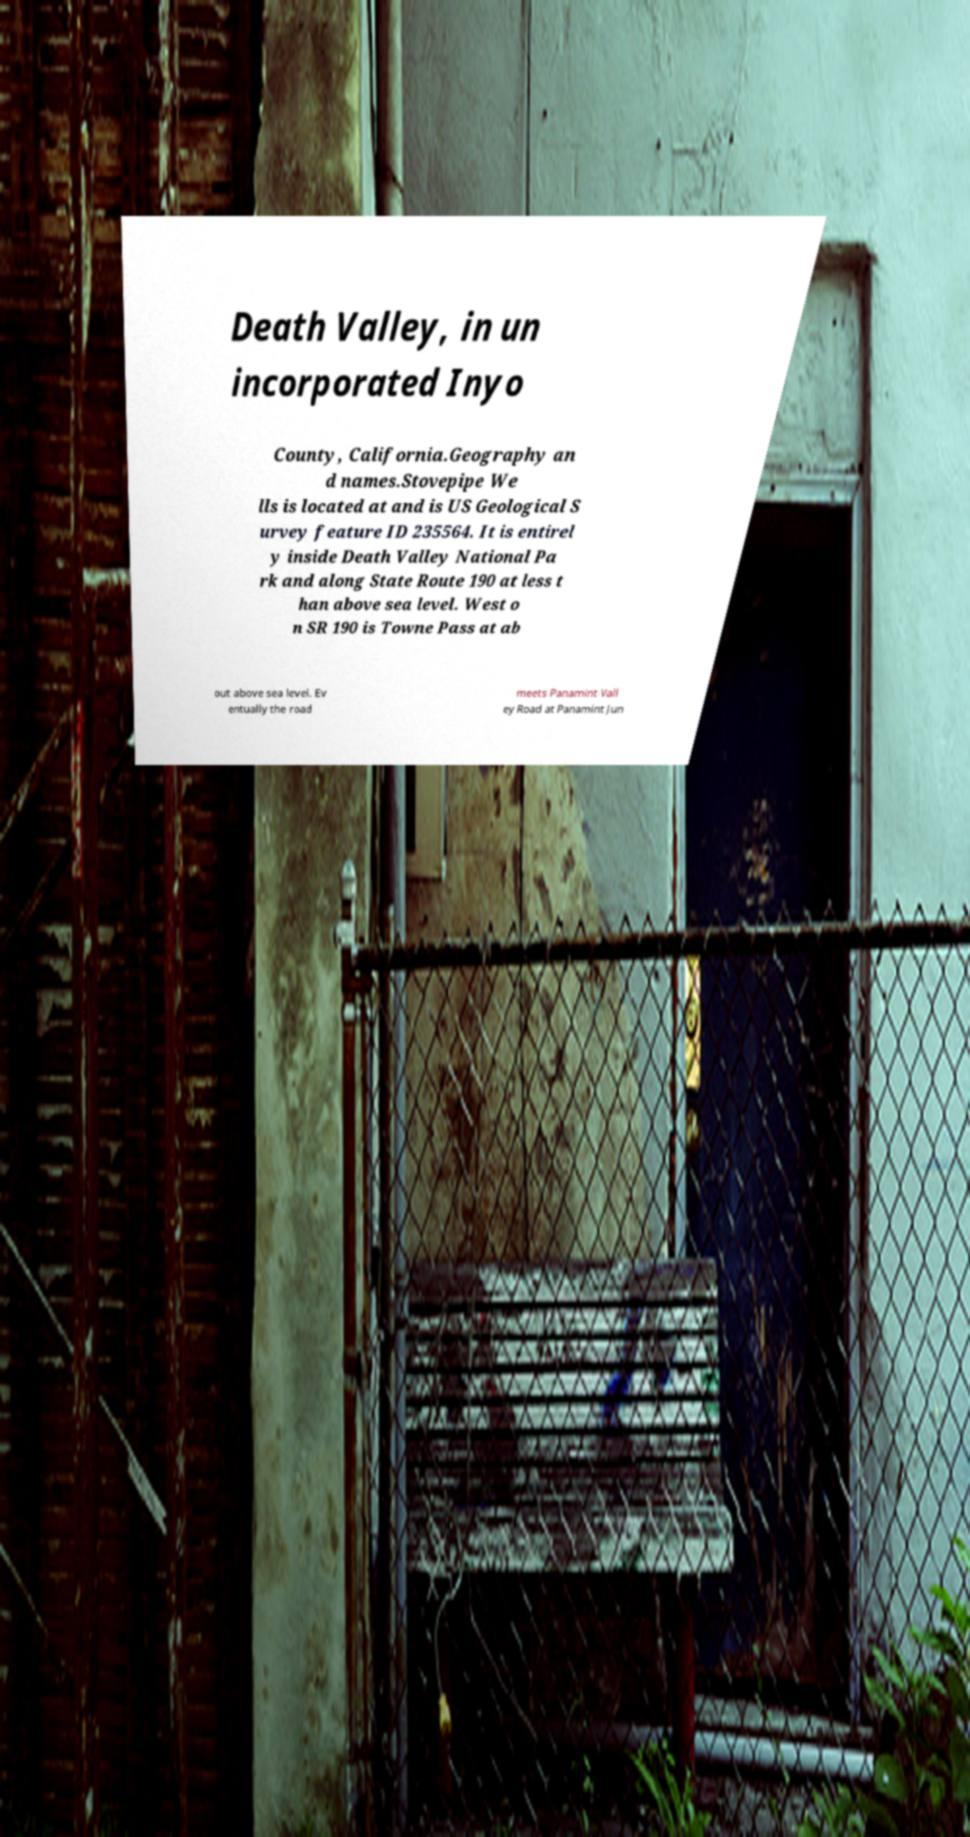Could you assist in decoding the text presented in this image and type it out clearly? Death Valley, in un incorporated Inyo County, California.Geography an d names.Stovepipe We lls is located at and is US Geological S urvey feature ID 235564. It is entirel y inside Death Valley National Pa rk and along State Route 190 at less t han above sea level. West o n SR 190 is Towne Pass at ab out above sea level. Ev entually the road meets Panamint Vall ey Road at Panamint Jun 